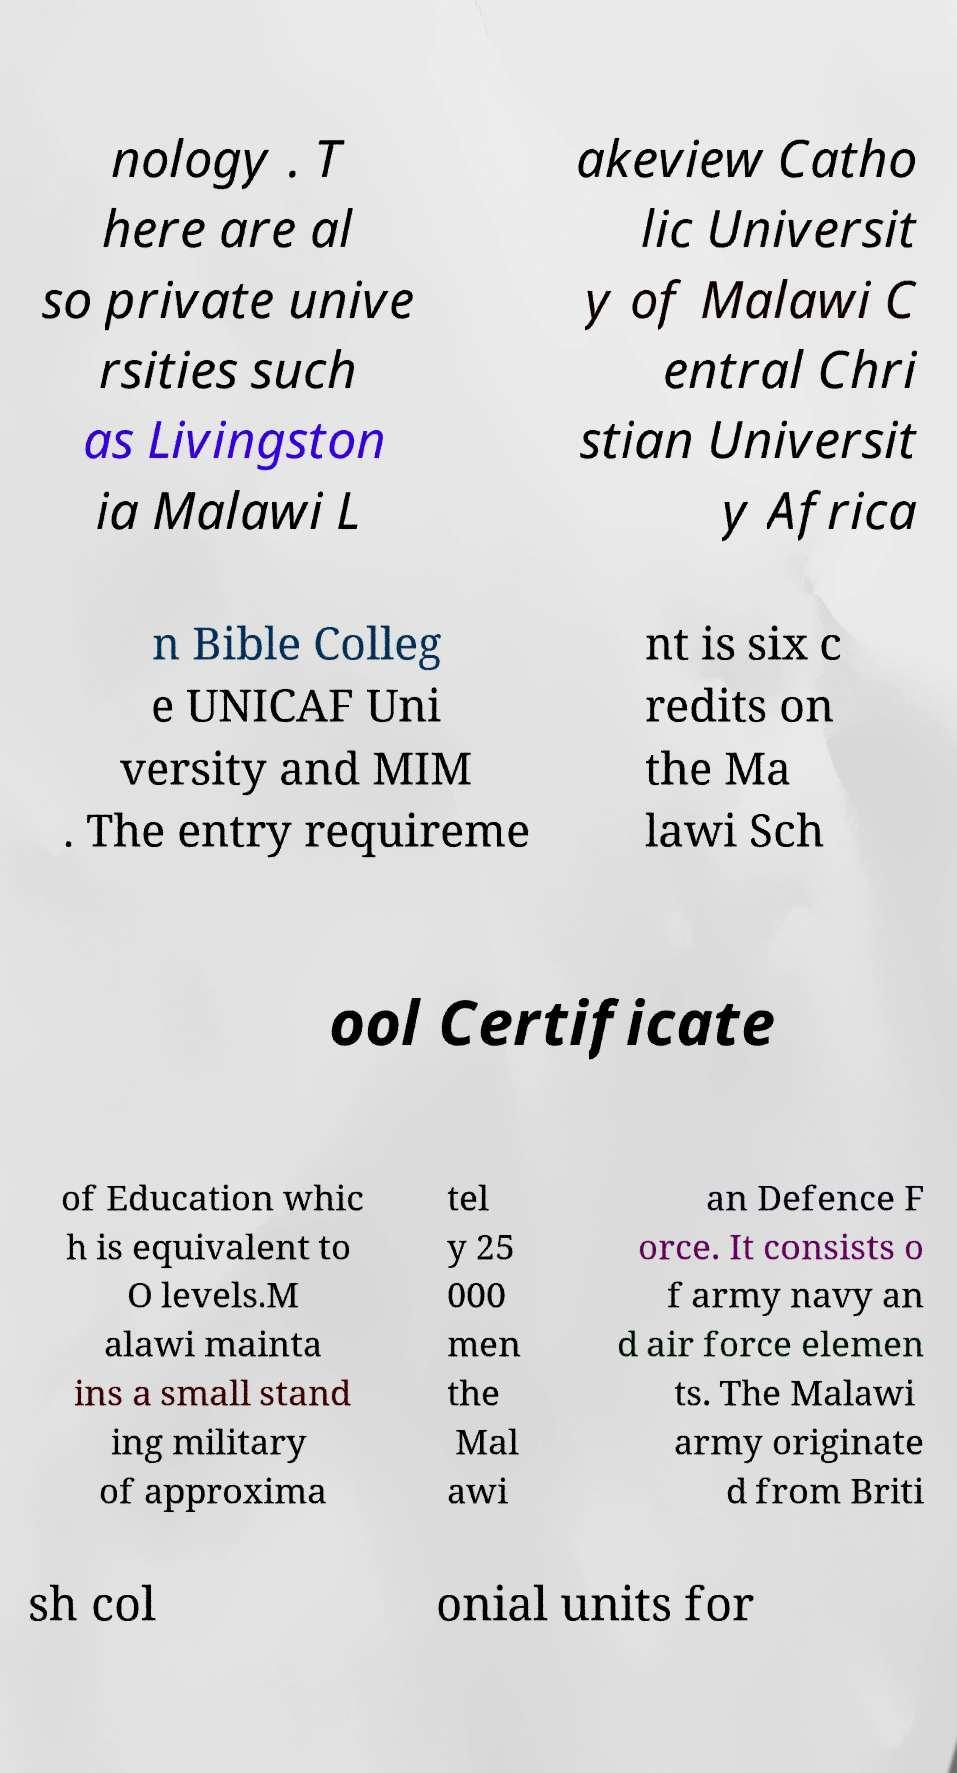Please identify and transcribe the text found in this image. nology . T here are al so private unive rsities such as Livingston ia Malawi L akeview Catho lic Universit y of Malawi C entral Chri stian Universit y Africa n Bible Colleg e UNICAF Uni versity and MIM . The entry requireme nt is six c redits on the Ma lawi Sch ool Certificate of Education whic h is equivalent to O levels.M alawi mainta ins a small stand ing military of approxima tel y 25 000 men the Mal awi an Defence F orce. It consists o f army navy an d air force elemen ts. The Malawi army originate d from Briti sh col onial units for 